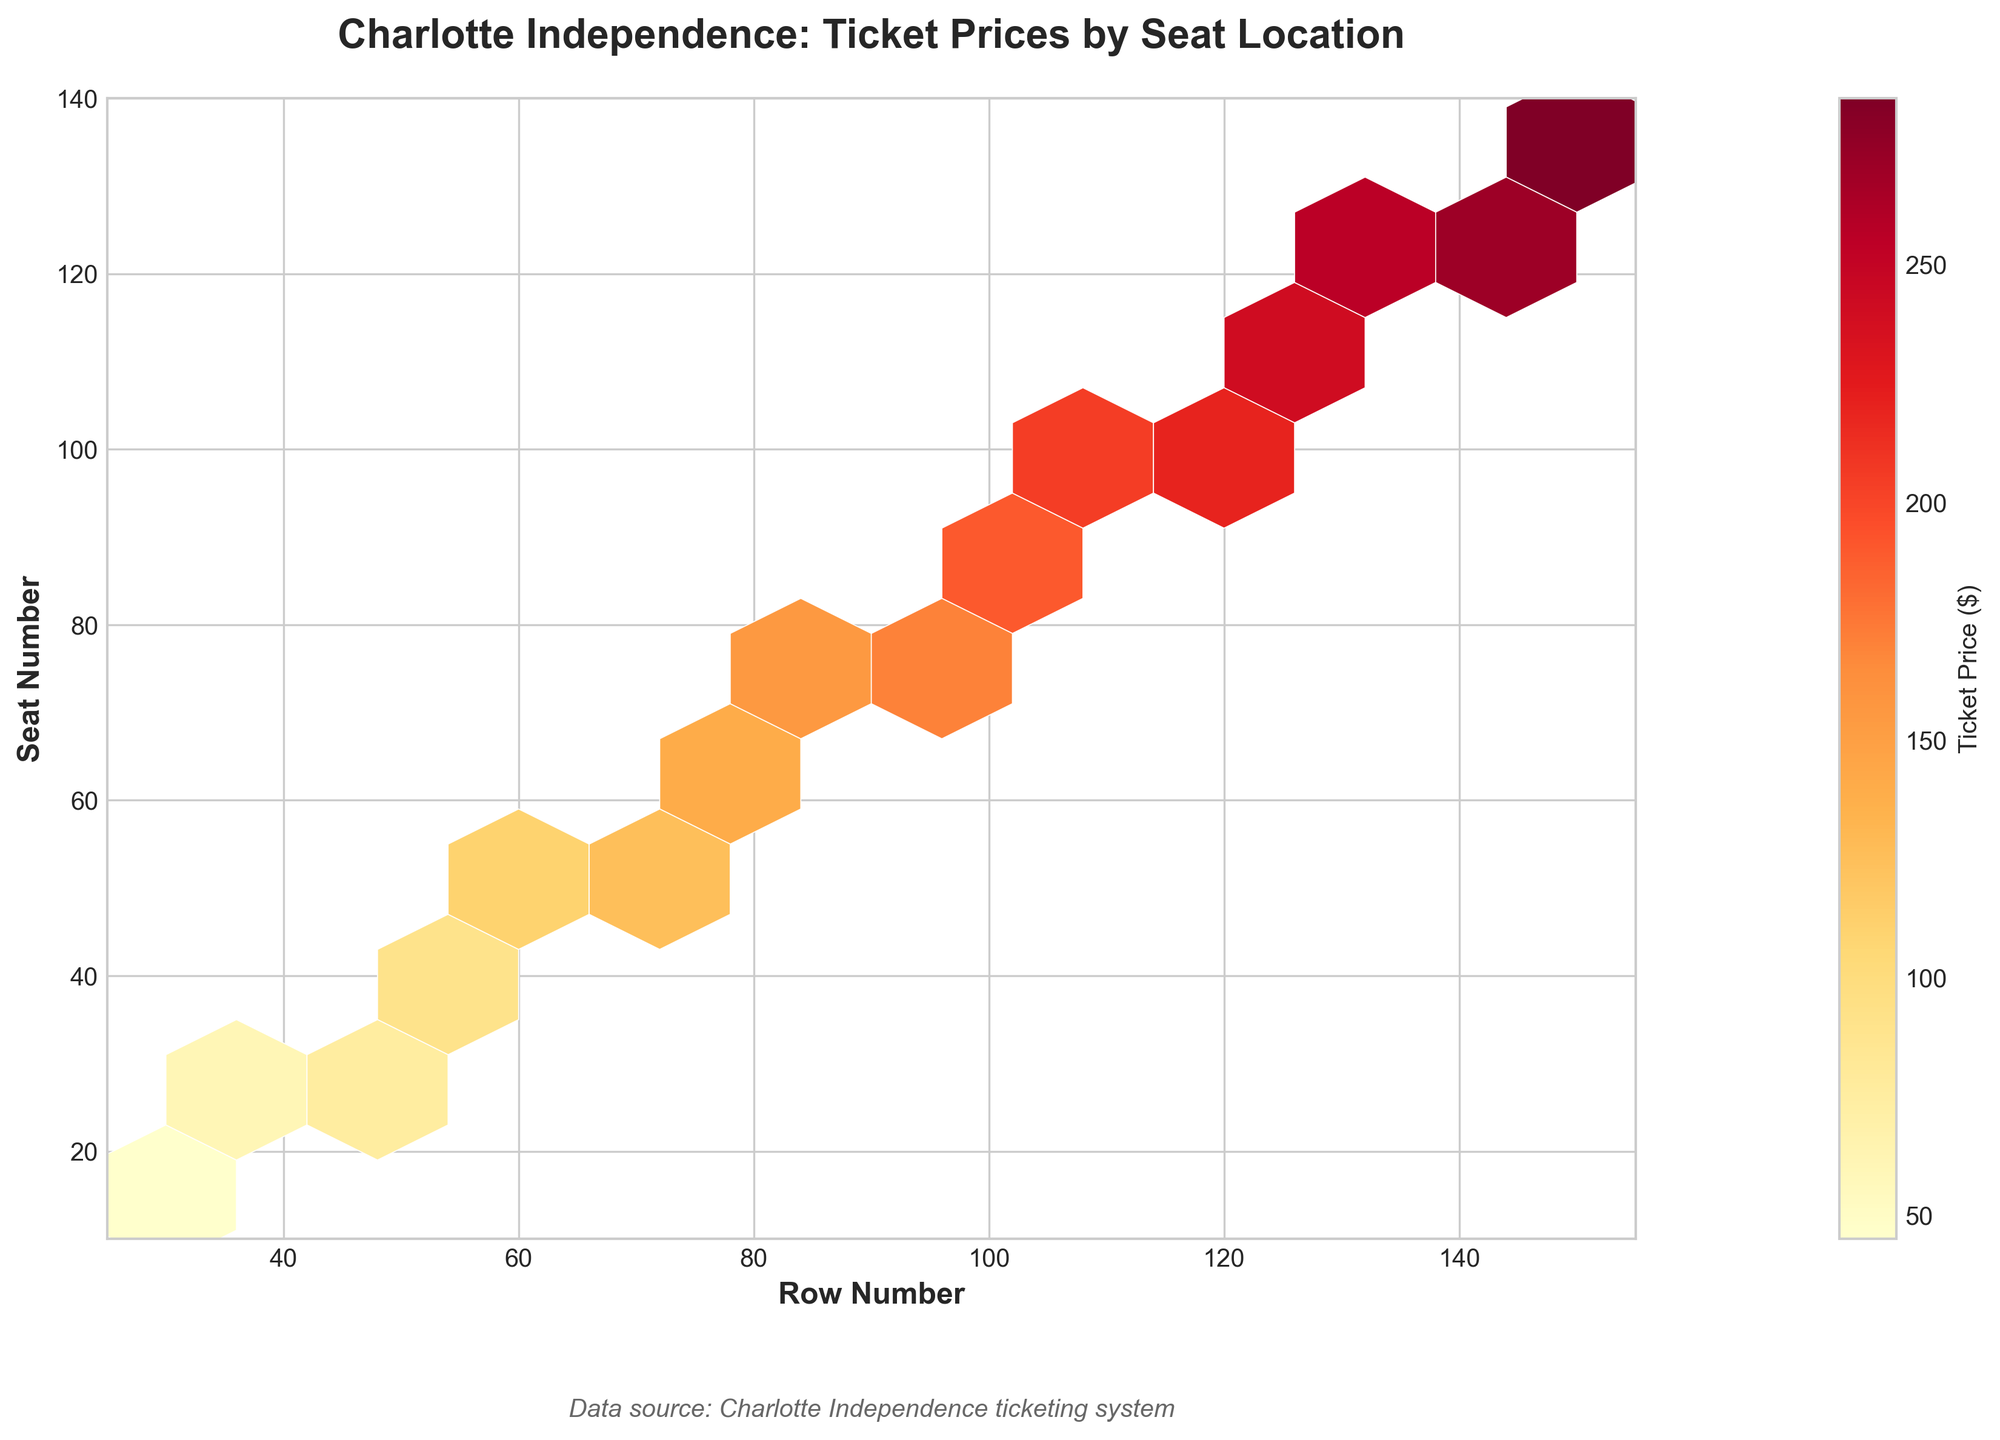What's the title of the figure? The title of the figure is located at the top center and usually provides a summary of the main topic depicted in the plot.
Answer: Charlotte Independence: Ticket Prices by Seat Location What are the x and y-axis labels? Axis labels are found next to the respective axes and describe what those axes represent. The x-axis label is to the left of the x-axis, and the y-axis label is to the bottom of the y-axis.
Answer: The x-axis is "Row Number" and the y-axis is "Seat Number" What does the color gradient represent in the hexbin plot? The color gradient in a hexbin plot is often used to illustrate a variable, in this case, the ticket prices. The color bar alongside the hexbin plot indicates what the colors represent.
Answer: Ticket Price ($) Which row number and seat number combination has the highest ticket price? Hexbin plots use darker or more intense colors to represent higher values. By examining the hexbin plot, the row and seat combination with the darkest color is identified.
Answer: Row 150 and Seat 135 How does ticket price tend to change as you move to higher row numbers and seat numbers? By looking over the hexbin plot from lower to higher row numbers and seat numbers, the relationship between ticket prices and these spatial variables can be inferred from the color intensities.
Answer: Ticket prices increase Comparing rows 30 and 140, which row has higher ticket prices on average? To compare, look at the color intensities of hexagons along both rows and identify whether the colors on average are darker for one of them.
Answer: Row 140 What is the range of the y-axis? Range refers to the interval covered by an axis. The y-axis shows the seat number and extends from its minimum to maximum value.
Answer: 10 to 140 What might be a reason for higher-priced tickets in certain areas? Higher prices are usually set for locations considered to provide a better view or experience. By identifying these, it can be inferred why certain areas have higher prices.
Answer: Proximity to better views or facilities What information does the color bar provide? The color bar explains the mapping between color intensities in the hexbin plot and the variable it represents. It ensures correct interpretation of the plot’s values based on color.
Answer: It shows ticket prices in dollars Are all seats equally priced irrespective of row and seat number? Examine the uniformity of the color distribution across the hexbin plot. If the colors vary substantially with location, this suggests price variance.
Answer: No 